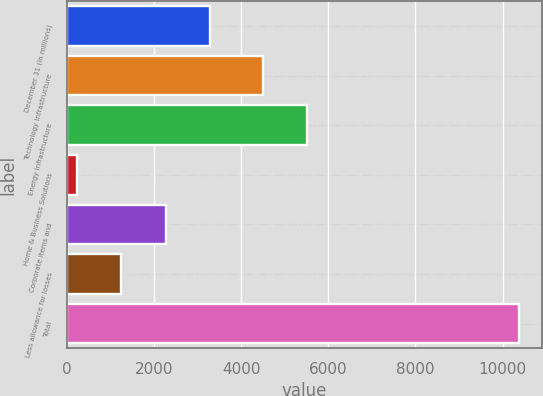Convert chart. <chart><loc_0><loc_0><loc_500><loc_500><bar_chart><fcel>December 31 (In millions)<fcel>Technology Infrastructure<fcel>Energy Infrastructure<fcel>Home & Business Solutions<fcel>Corporate items and<fcel>Less allowance for losses<fcel>Total<nl><fcel>3282.9<fcel>4502<fcel>5516.3<fcel>240<fcel>2268.6<fcel>1254.3<fcel>10383<nl></chart> 